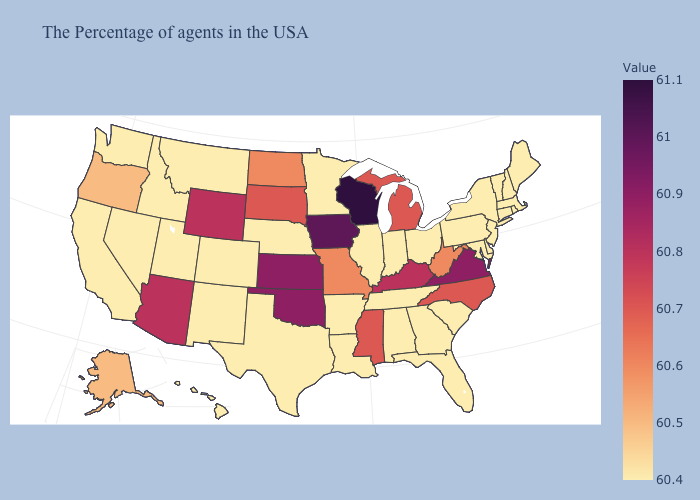Which states hav the highest value in the MidWest?
Give a very brief answer. Wisconsin. Does Wisconsin have the highest value in the USA?
Keep it brief. Yes. Does South Carolina have a higher value than Michigan?
Give a very brief answer. No. Among the states that border Nebraska , does Missouri have the lowest value?
Be succinct. No. Does Virginia have the lowest value in the USA?
Write a very short answer. No. 